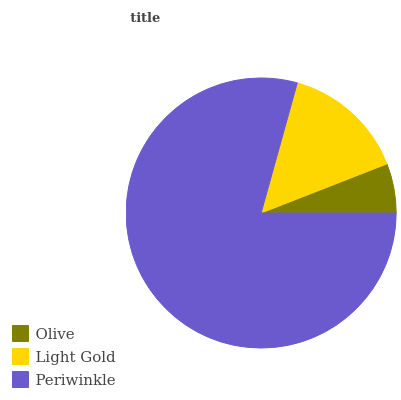Is Olive the minimum?
Answer yes or no. Yes. Is Periwinkle the maximum?
Answer yes or no. Yes. Is Light Gold the minimum?
Answer yes or no. No. Is Light Gold the maximum?
Answer yes or no. No. Is Light Gold greater than Olive?
Answer yes or no. Yes. Is Olive less than Light Gold?
Answer yes or no. Yes. Is Olive greater than Light Gold?
Answer yes or no. No. Is Light Gold less than Olive?
Answer yes or no. No. Is Light Gold the high median?
Answer yes or no. Yes. Is Light Gold the low median?
Answer yes or no. Yes. Is Periwinkle the high median?
Answer yes or no. No. Is Olive the low median?
Answer yes or no. No. 